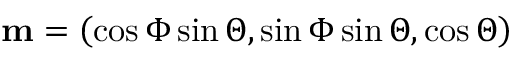Convert formula to latex. <formula><loc_0><loc_0><loc_500><loc_500>m = \left ( \cos \Phi \sin \Theta , \sin \Phi \sin \Theta , \cos \Theta \right )</formula> 